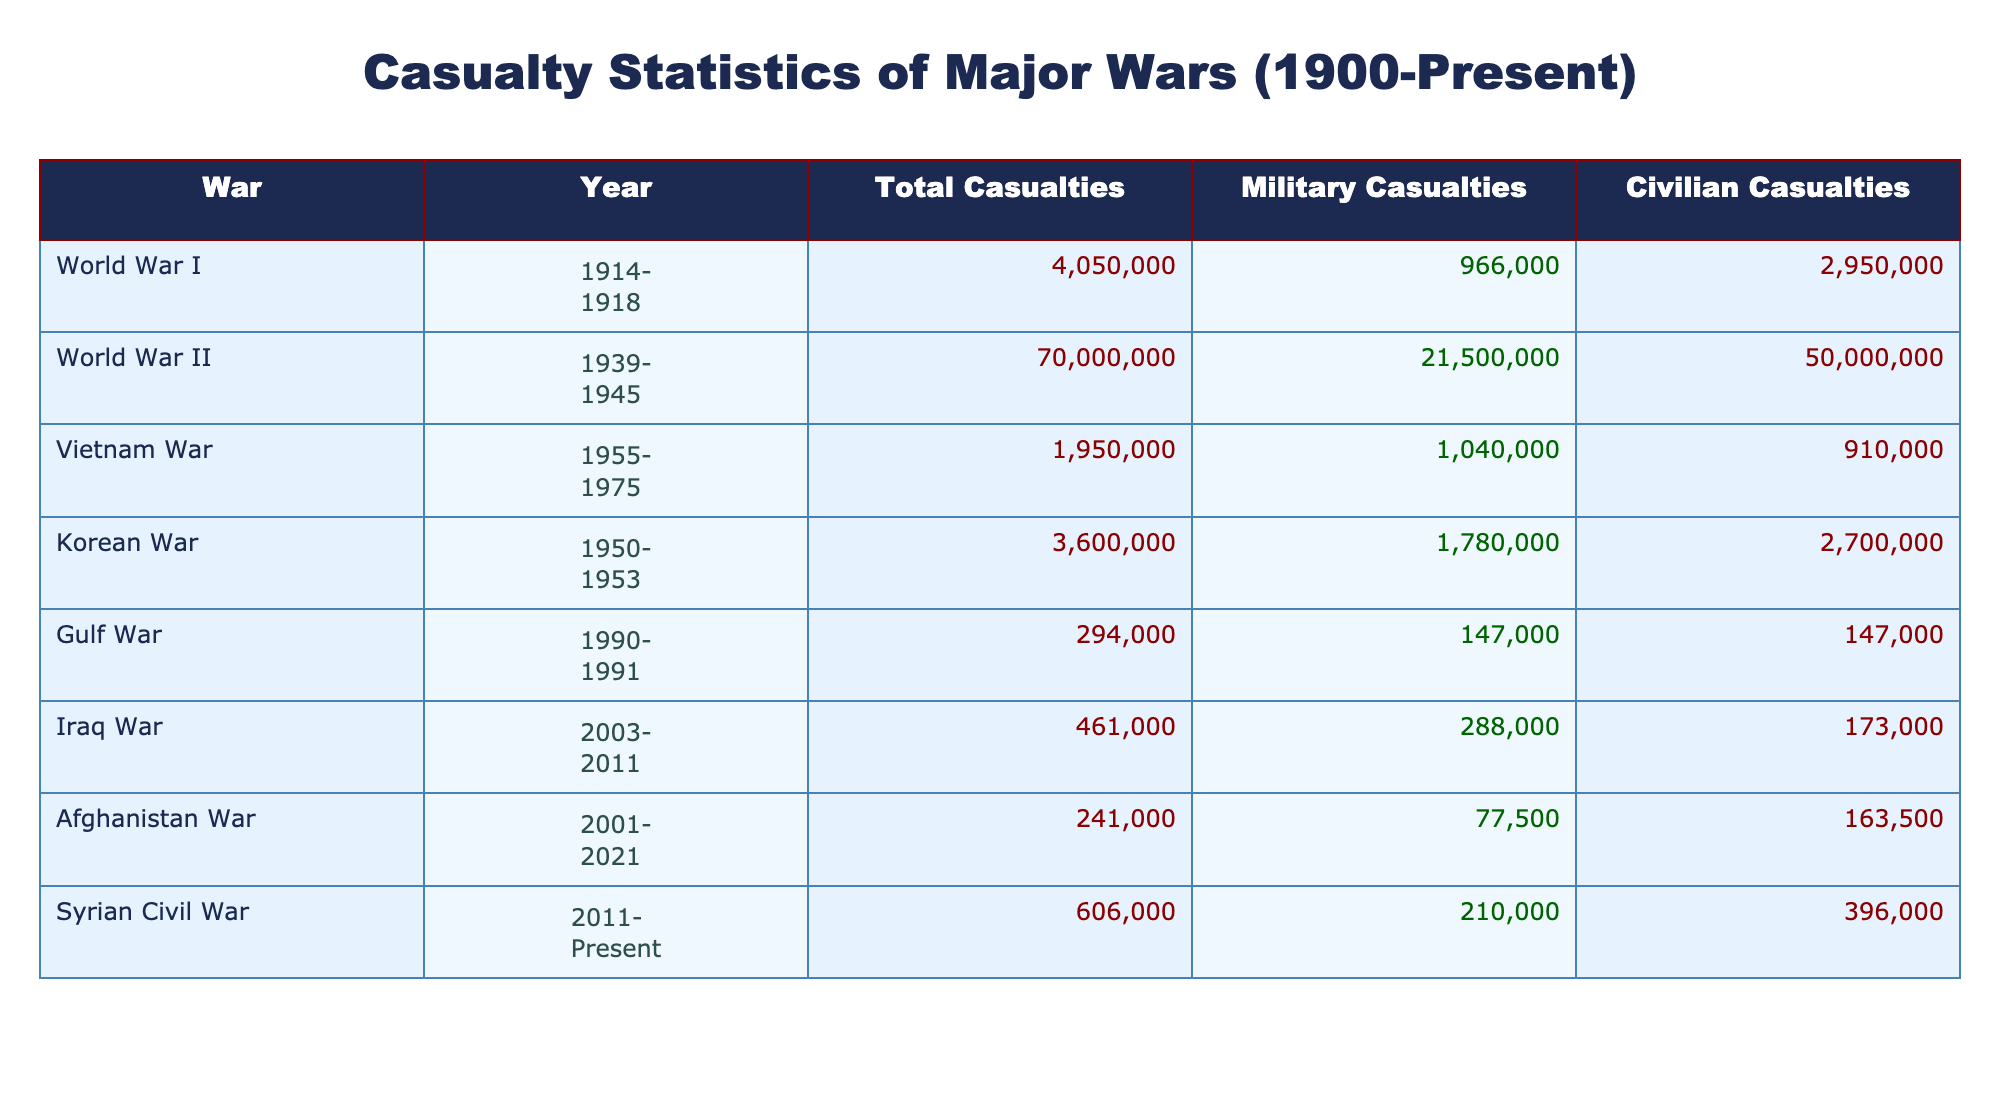What was the total number of casualties in World War II? According to the table, the total casualties for World War II are listed directly under the "Total Casualties" column for that specific war, which shows 70000000.
Answer: 70000000 How many civilian casualties were reported during the Vietnam War? The table specifies the number of civilian casualties for the Vietnam War in the corresponding row, which is stated as 910000 in the "Civilian Casualties" column.
Answer: 910000 What is the difference between military and civilian casualties in the Korean War? To find the difference, we subtract the number of civilian casualties (2700000) from military casualties (1780000). This calculation gives us a difference of 1780000 - 2700000 = -920000, indicating there were more civilian casualties.
Answer: 920000 Which war had the highest total casualties? By reviewing the "Total Casualties" column across all wars, it's clear that World War II has the highest figure at 70000000, significantly more than any other conflict listed.
Answer: World War II Is it true that the Gulf War had more civilian casualties than military casualties? Looking at the Gulf War row, military casualties are 147000, and civilian casualties are also 147000. Since they are equal, the statement is false.
Answer: False What was the average number of total casualties across all listed wars? The total casualties from each war are summed: 4050000 + 70000000 + 1950000 + 3600000 + 294000 + 461000 + 241000 + 606000 = 79880000. There are 8 wars, so the average is 79880000 / 8 = 9985000.
Answer: 9985000 How many casualties did the Syrian Civil War have compared to the Afghanistan War combined? For the Syrian Civil War, the total casualties are 606000, and for the Afghanistan War, they are 241000. Combining these gives us 606000 + 241000 = 847000 in total casualties for both wars.
Answer: 847000 Which war had the least total casualties? By examining the "Total Casualties" column, we can identify that the Gulf War had the least total casualties at 294000 compared to the other listed conflicts.
Answer: Gulf War Did the Iraq War have more military casualties than the Afghan War? For the Iraq War, military casualties are 288000, and for the Afghanistan War, they are 77500. Since 288000 is greater than 77500, this statement is true.
Answer: True 